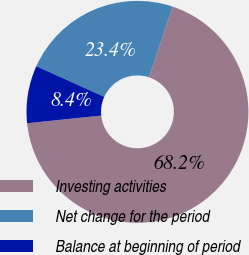Convert chart. <chart><loc_0><loc_0><loc_500><loc_500><pie_chart><fcel>Investing activities<fcel>Net change for the period<fcel>Balance at beginning of period<nl><fcel>68.23%<fcel>23.38%<fcel>8.39%<nl></chart> 